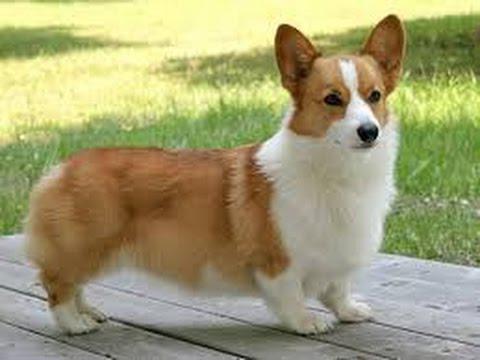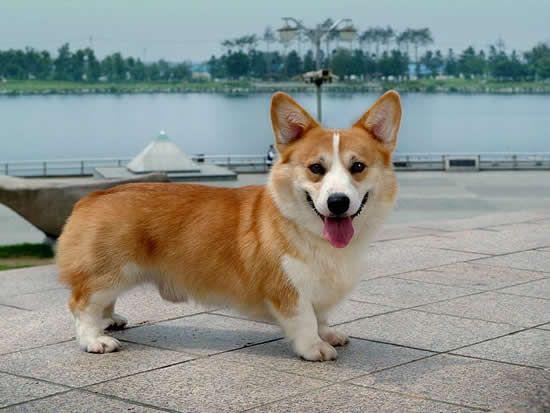The first image is the image on the left, the second image is the image on the right. Examine the images to the left and right. Is the description "There are exactly two dogs and both of them are outdoors." accurate? Answer yes or no. Yes. The first image is the image on the left, the second image is the image on the right. For the images shown, is this caption "All dogs are standing on all fours with their bodies aimed rightward, and at least one dog has its head turned to face the camera." true? Answer yes or no. Yes. 